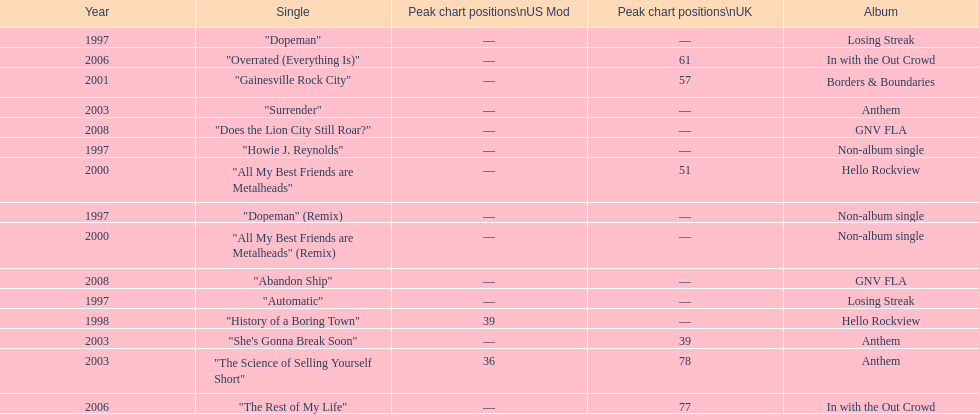Compare the chart positions between the us and the uk for the science of selling yourself short, where did it do better? US. 